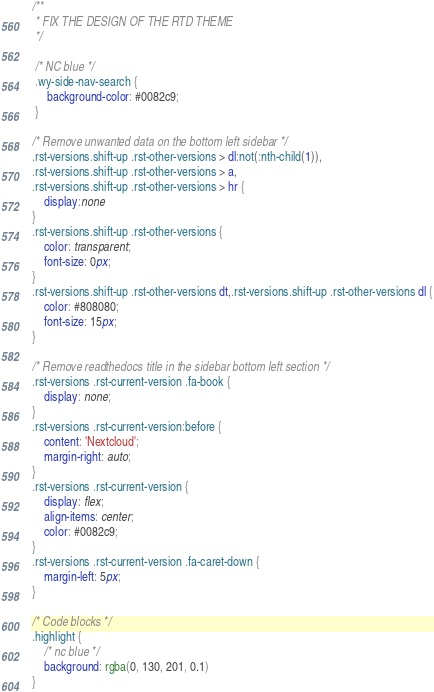<code> <loc_0><loc_0><loc_500><loc_500><_CSS_>/**
 * FIX THE DESIGN OF THE RTD THEME
 */

 /* NC blue */
 .wy-side-nav-search {
	 background-color: #0082c9;
 }

/* Remove unwanted data on the bottom left sidebar */
.rst-versions.shift-up .rst-other-versions > dl:not(:nth-child(1)),
.rst-versions.shift-up .rst-other-versions > a,
.rst-versions.shift-up .rst-other-versions > hr {
 	display:none
}
.rst-versions.shift-up .rst-other-versions {
	color: transparent;
	font-size: 0px;
}
.rst-versions.shift-up .rst-other-versions dt,.rst-versions.shift-up .rst-other-versions dl {
	color: #808080;
	font-size: 15px;
}

/* Remove readthedocs title in the sidebar bottom left section */
.rst-versions .rst-current-version .fa-book {
	display: none;
}
.rst-versions .rst-current-version:before {
	content: 'Nextcloud';
	margin-right: auto;
}
.rst-versions .rst-current-version {
	display: flex;
	align-items: center;
	color: #0082c9;
}
.rst-versions .rst-current-version .fa-caret-down {
	margin-left: 5px;
}

/* Code blocks */
.highlight {
	/* nc blue */
	background: rgba(0, 130, 201, 0.1)
}</code> 